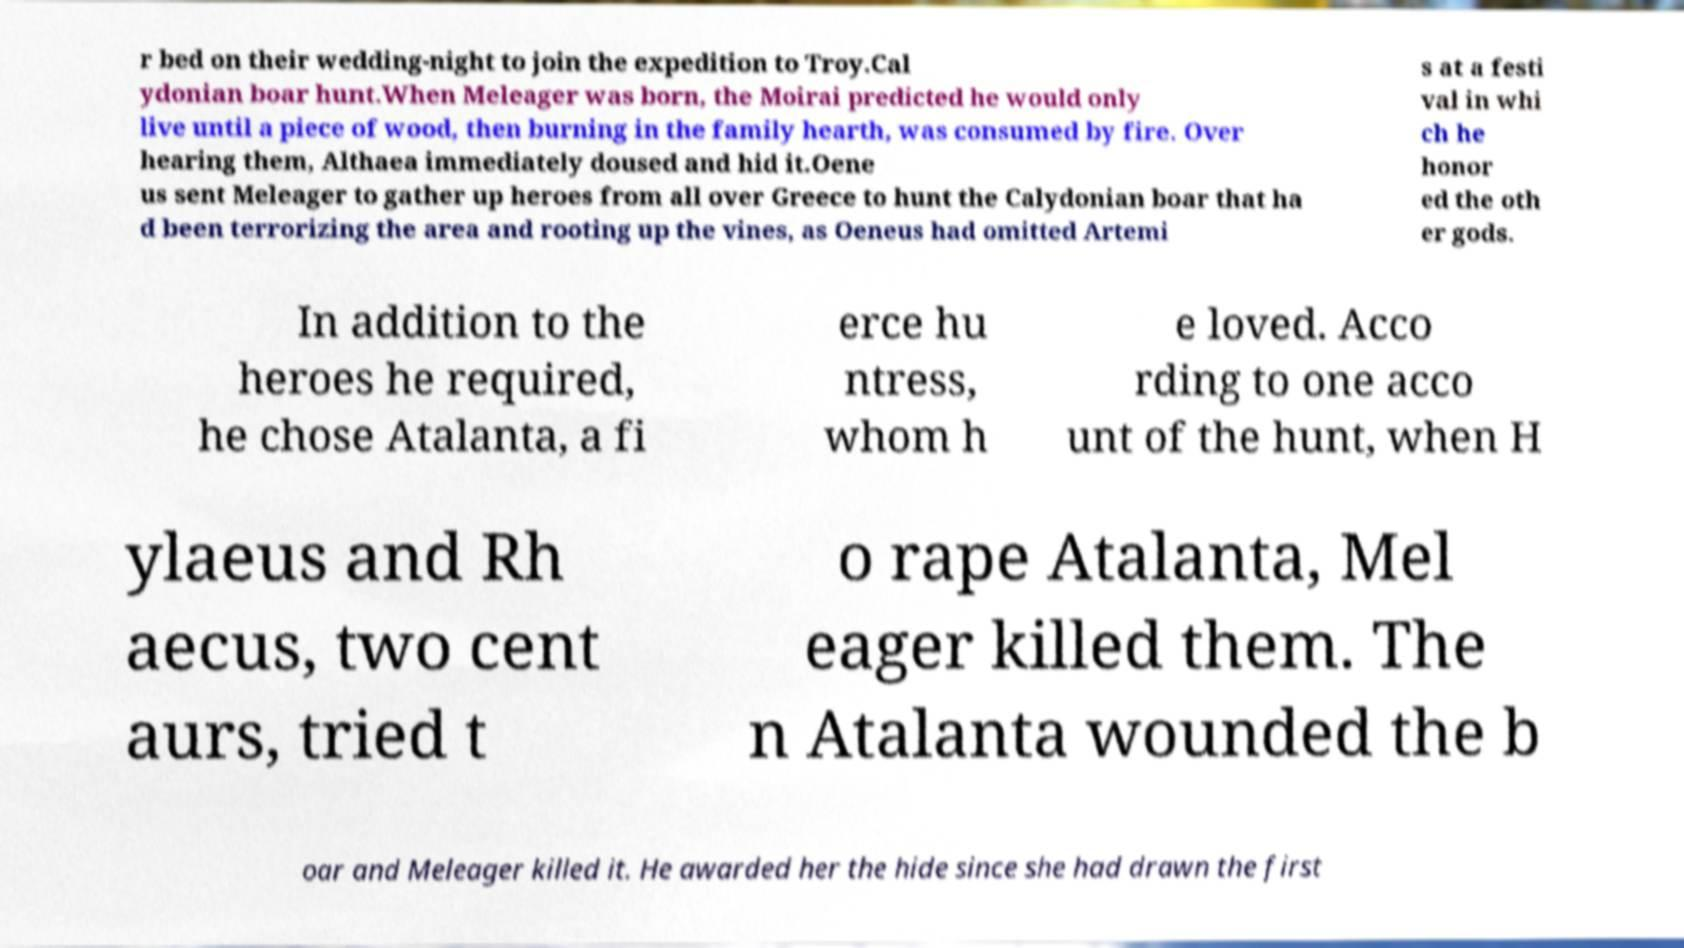I need the written content from this picture converted into text. Can you do that? r bed on their wedding-night to join the expedition to Troy.Cal ydonian boar hunt.When Meleager was born, the Moirai predicted he would only live until a piece of wood, then burning in the family hearth, was consumed by fire. Over hearing them, Althaea immediately doused and hid it.Oene us sent Meleager to gather up heroes from all over Greece to hunt the Calydonian boar that ha d been terrorizing the area and rooting up the vines, as Oeneus had omitted Artemi s at a festi val in whi ch he honor ed the oth er gods. In addition to the heroes he required, he chose Atalanta, a fi erce hu ntress, whom h e loved. Acco rding to one acco unt of the hunt, when H ylaeus and Rh aecus, two cent aurs, tried t o rape Atalanta, Mel eager killed them. The n Atalanta wounded the b oar and Meleager killed it. He awarded her the hide since she had drawn the first 